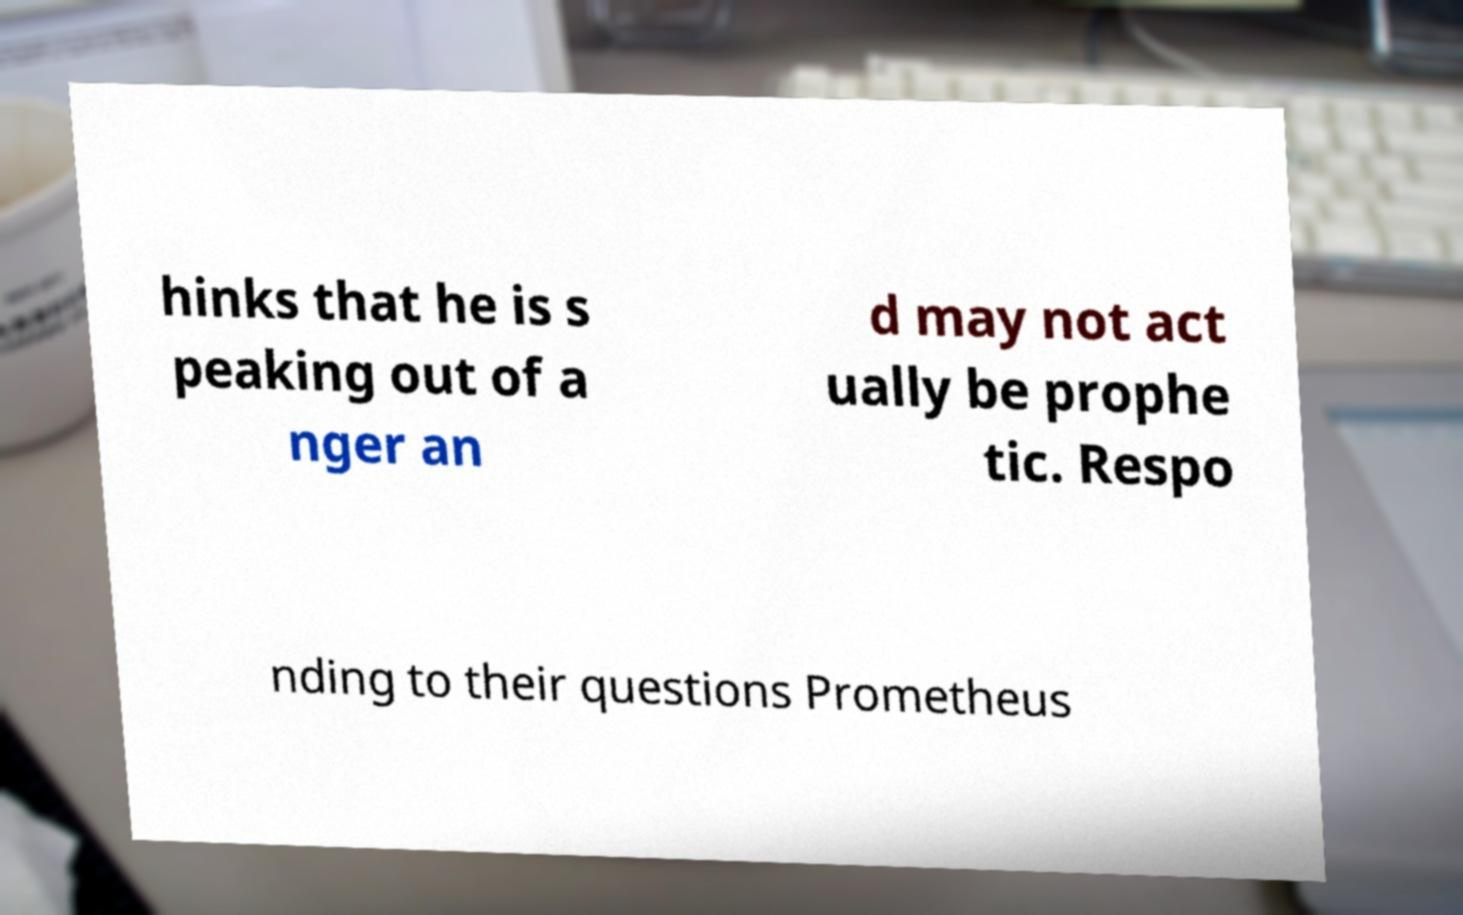For documentation purposes, I need the text within this image transcribed. Could you provide that? hinks that he is s peaking out of a nger an d may not act ually be prophe tic. Respo nding to their questions Prometheus 